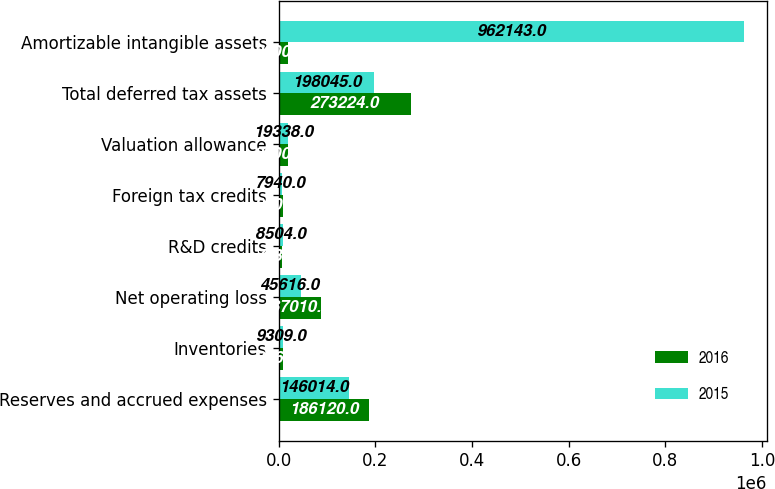Convert chart to OTSL. <chart><loc_0><loc_0><loc_500><loc_500><stacked_bar_chart><ecel><fcel>Reserves and accrued expenses<fcel>Inventories<fcel>Net operating loss<fcel>R&D credits<fcel>Foreign tax credits<fcel>Valuation allowance<fcel>Total deferred tax assets<fcel>Amortizable intangible assets<nl><fcel>2016<fcel>186120<fcel>8967<fcel>87010<fcel>7933<fcel>9203<fcel>20009<fcel>273224<fcel>20009<nl><fcel>2015<fcel>146014<fcel>9309<fcel>45616<fcel>8504<fcel>7940<fcel>19338<fcel>198045<fcel>962143<nl></chart> 